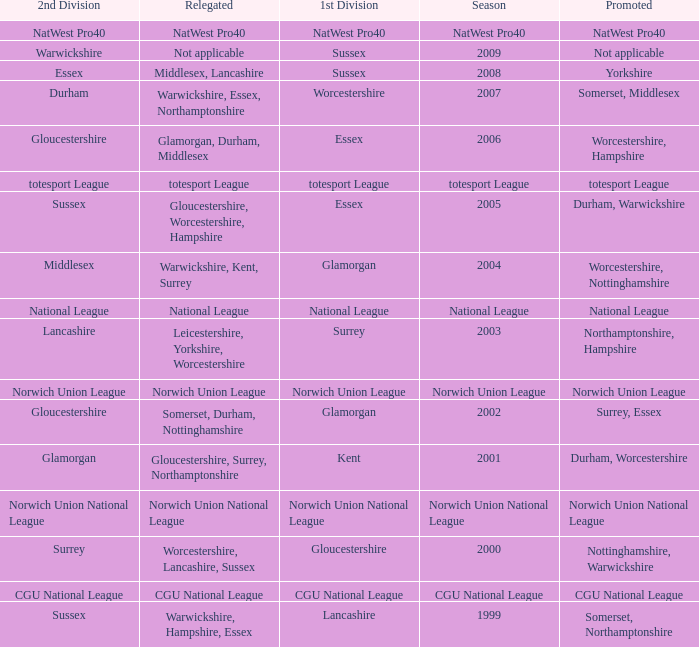What is the 1st division when the 2nd division is national league? National League. 